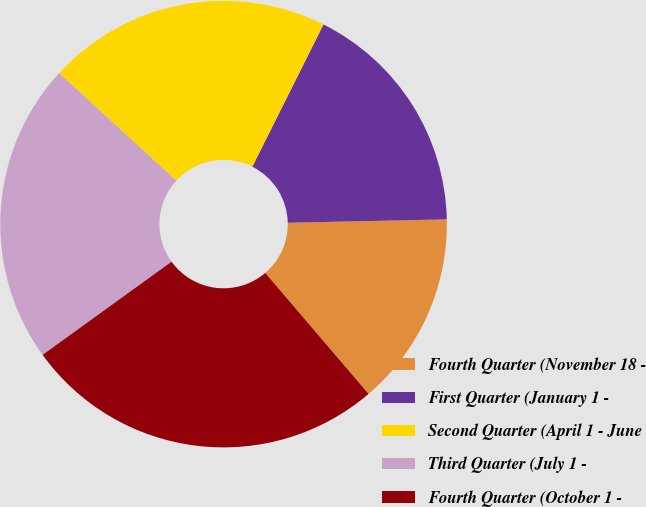Convert chart to OTSL. <chart><loc_0><loc_0><loc_500><loc_500><pie_chart><fcel>Fourth Quarter (November 18 -<fcel>First Quarter (January 1 -<fcel>Second Quarter (April 1 - June<fcel>Third Quarter (July 1 -<fcel>Fourth Quarter (October 1 -<nl><fcel>14.09%<fcel>17.28%<fcel>20.56%<fcel>21.78%<fcel>26.29%<nl></chart> 